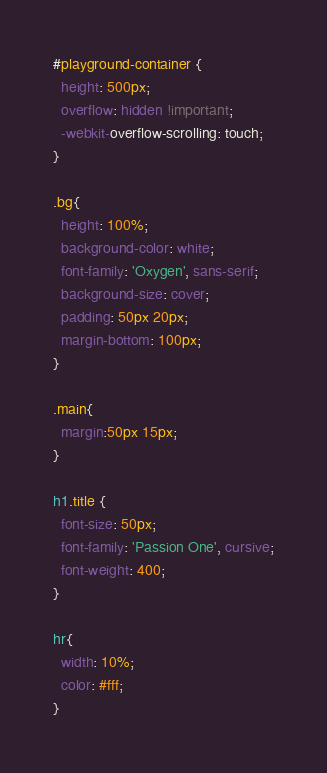<code> <loc_0><loc_0><loc_500><loc_500><_CSS_>#playground-container {
  height: 500px;
  overflow: hidden !important;
  -webkit-overflow-scrolling: touch;
}

.bg{
  height: 100%;
  background-color: white;
  font-family: 'Oxygen', sans-serif;
  background-size: cover;
  padding: 50px 20px;
  margin-bottom: 100px;
}

.main{
  margin:50px 15px;
}

h1.title {
  font-size: 50px;
  font-family: 'Passion One', cursive;
  font-weight: 400;
}

hr{
  width: 10%;
  color: #fff;
}
</code> 